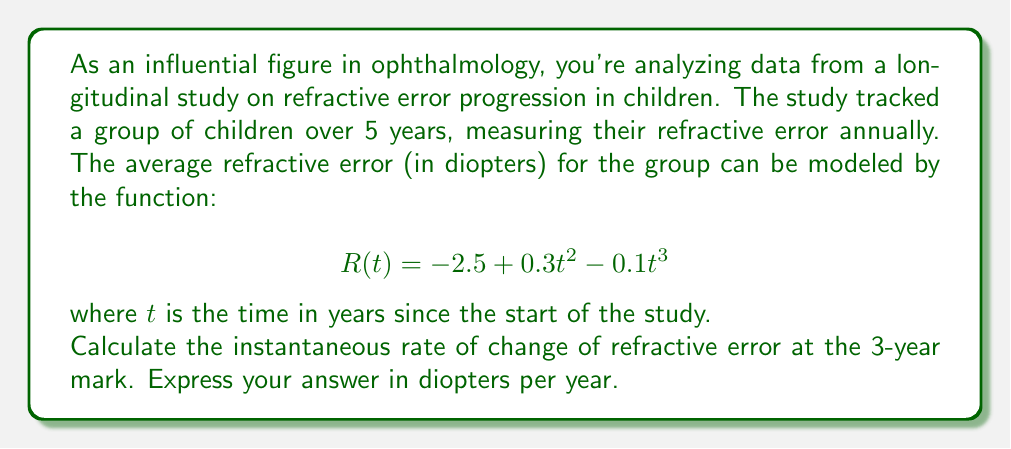Help me with this question. To find the instantaneous rate of change at a specific point, we need to calculate the derivative of the function $R(t)$ and then evaluate it at $t = 3$.

1) First, let's find the derivative of $R(t)$:
   
   $$R(t) = -2.5 + 0.3t^2 - 0.1t^3$$
   
   $$R'(t) = 0.6t - 0.3t^2$$

2) Now, we evaluate $R'(t)$ at $t = 3$:
   
   $$R'(3) = 0.6(3) - 0.3(3)^2$$
   
   $$= 1.8 - 0.3(9)$$
   
   $$= 1.8 - 2.7$$
   
   $$= -0.9$$

3) The negative value indicates that the refractive error is decreasing (becoming more myopic) at this point in time.

4) The units of this rate are diopters per year, as we're measuring the change in refractive error (diopters) with respect to time (years).
Answer: $-0.9$ diopters per year 